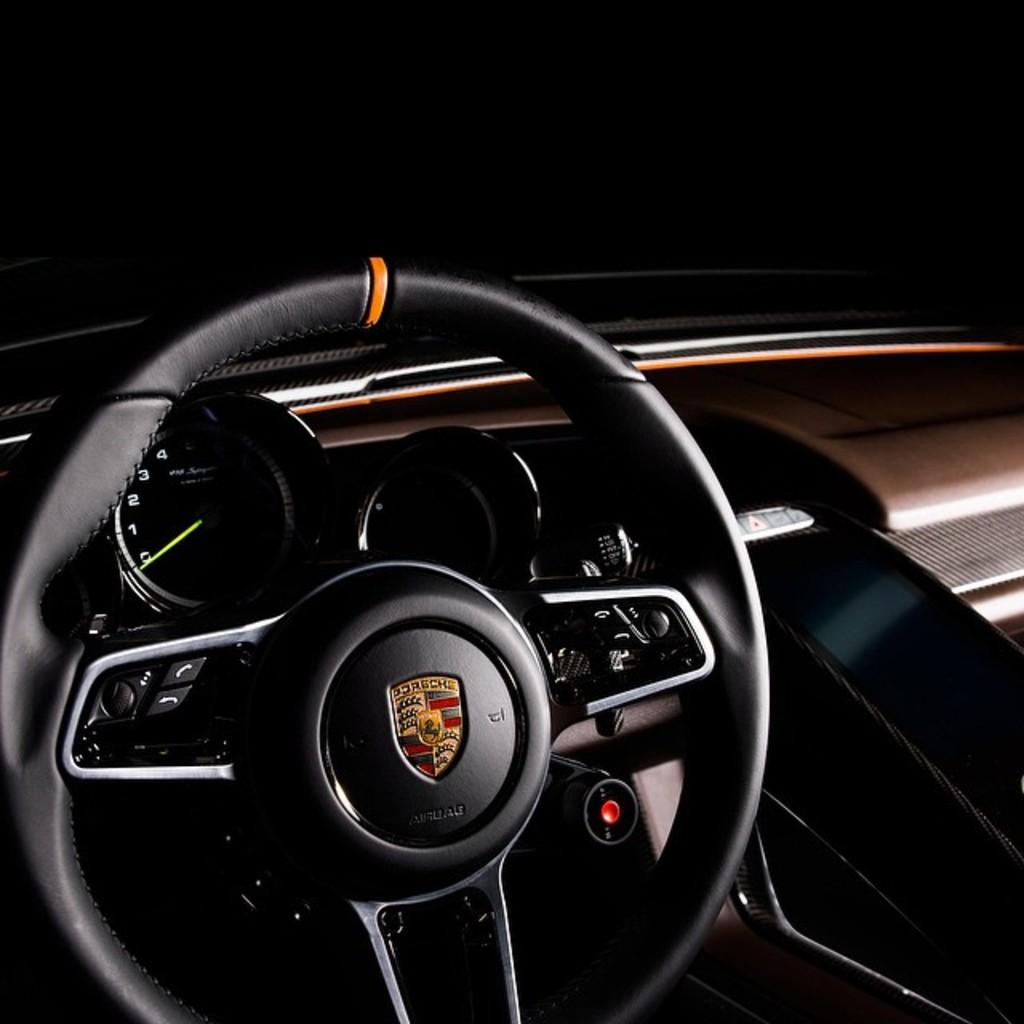Where was the image taken? The image was taken inside a vehicle. What can be seen on the left side of the image? There is a steering wheel on the left side of the image. What instrument is visible in the image for monitoring the vehicle's performance? There is a meter indicator visible in the image. What type of writing can be seen on the steering wheel in the image? There is no writing visible on the steering wheel in the image. Can you see any celery or squirrels in the image? No, there are no celery or squirrels present in the image. 